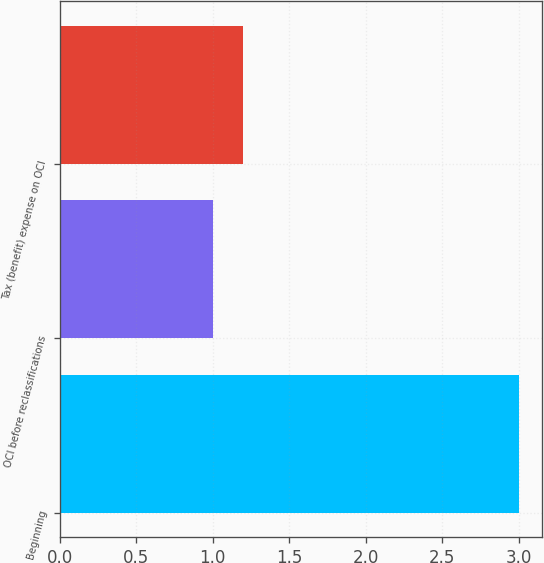<chart> <loc_0><loc_0><loc_500><loc_500><bar_chart><fcel>Beginning<fcel>OCI before reclassifications<fcel>Tax (benefit) expense on OCI<nl><fcel>3<fcel>1<fcel>1.2<nl></chart> 